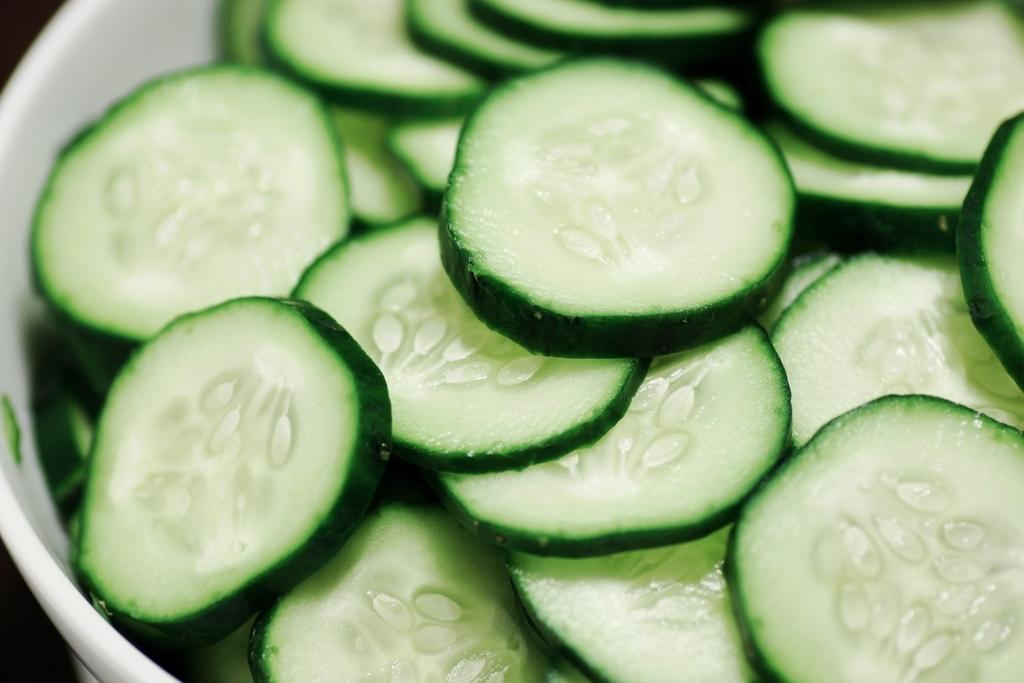What color is the bowl in the image? The bowl in the image is white. What is inside the bowl? The bowl contains chopped cucumbers. What type of brass instrument can be seen in the image? There is no brass instrument present in the image; it features a white bowl with chopped cucumbers. Is there a doctor in the image? There is no doctor present in the image; it features a white bowl with chopped cucumbers. 